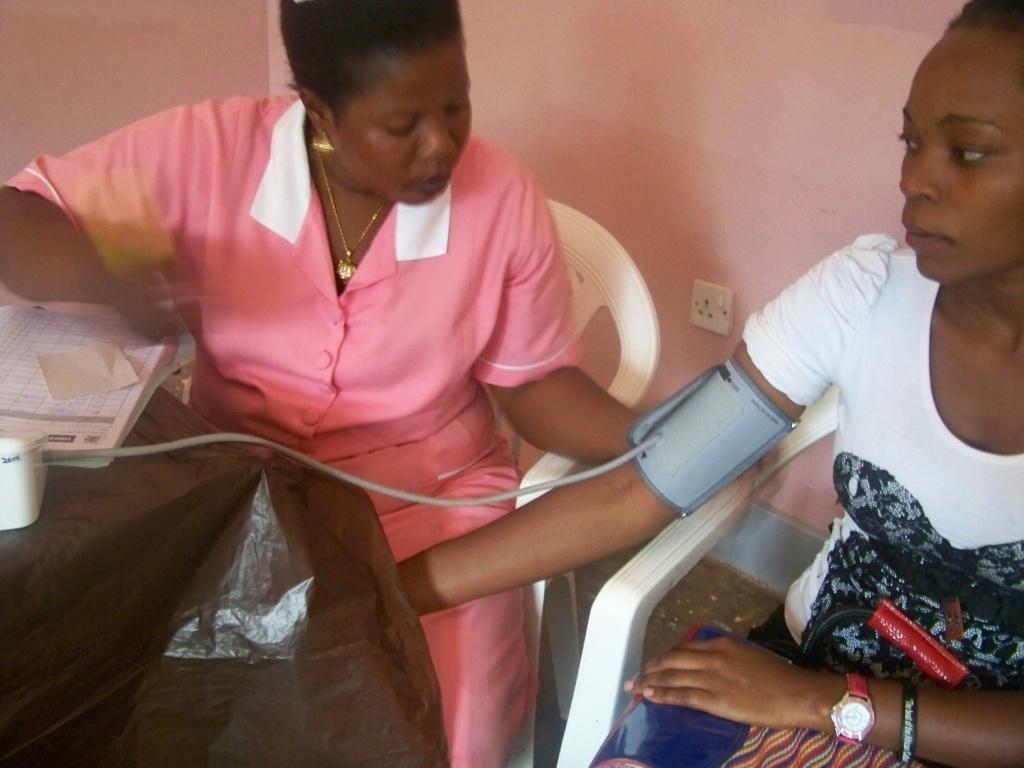In one or two sentences, can you explain what this image depicts? In this image a woman is sitting on the chair. Beside there is a woman sitting on the chair and she is having a bag on her lap. Left side there is a table having a machine and a book on it. Behind them there is a wall. 